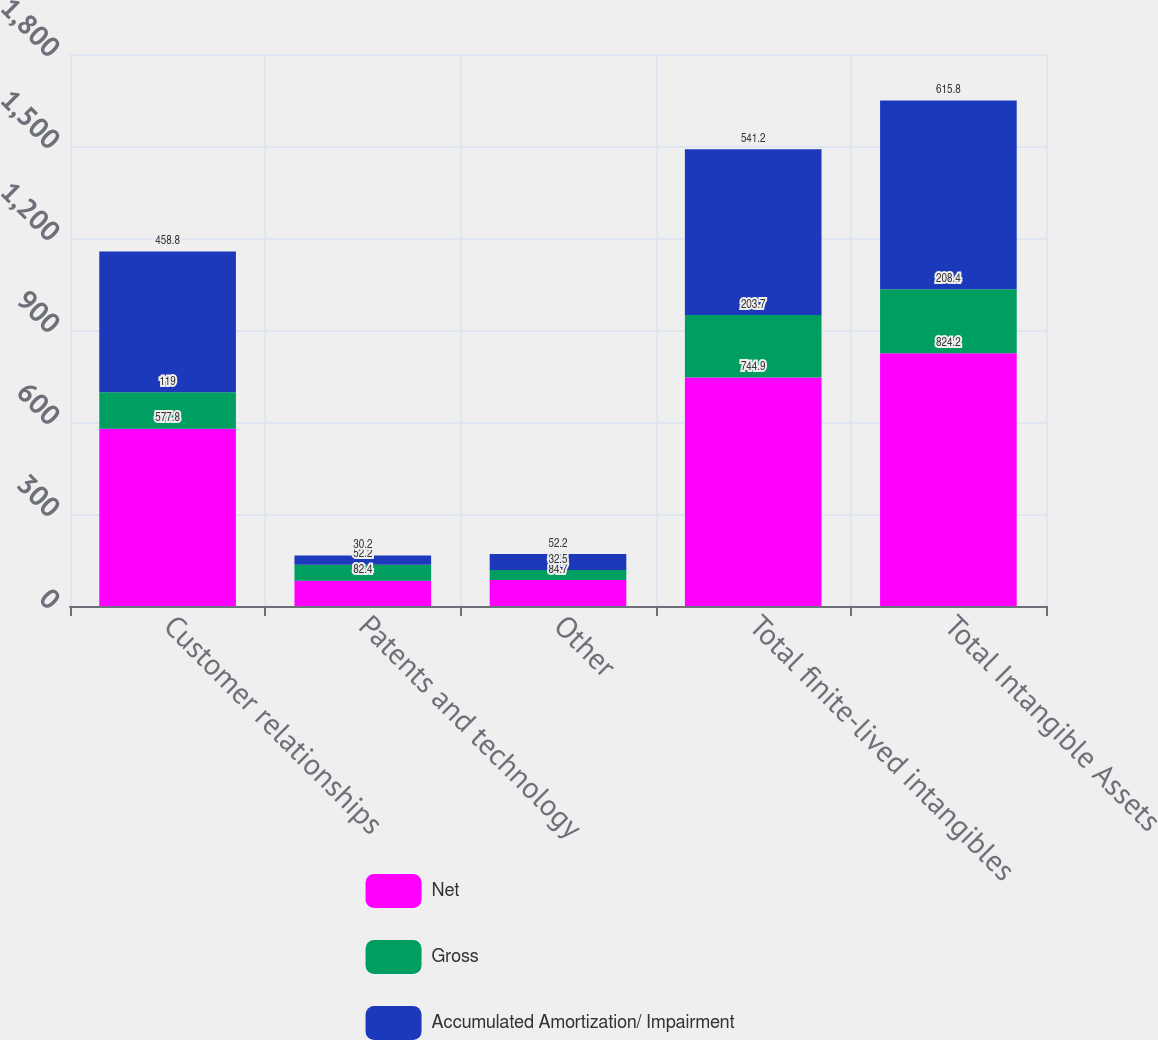<chart> <loc_0><loc_0><loc_500><loc_500><stacked_bar_chart><ecel><fcel>Customer relationships<fcel>Patents and technology<fcel>Other<fcel>Total finite-lived intangibles<fcel>Total Intangible Assets<nl><fcel>Net<fcel>577.8<fcel>82.4<fcel>84.7<fcel>744.9<fcel>824.2<nl><fcel>Gross<fcel>119<fcel>52.2<fcel>32.5<fcel>203.7<fcel>208.4<nl><fcel>Accumulated Amortization/ Impairment<fcel>458.8<fcel>30.2<fcel>52.2<fcel>541.2<fcel>615.8<nl></chart> 